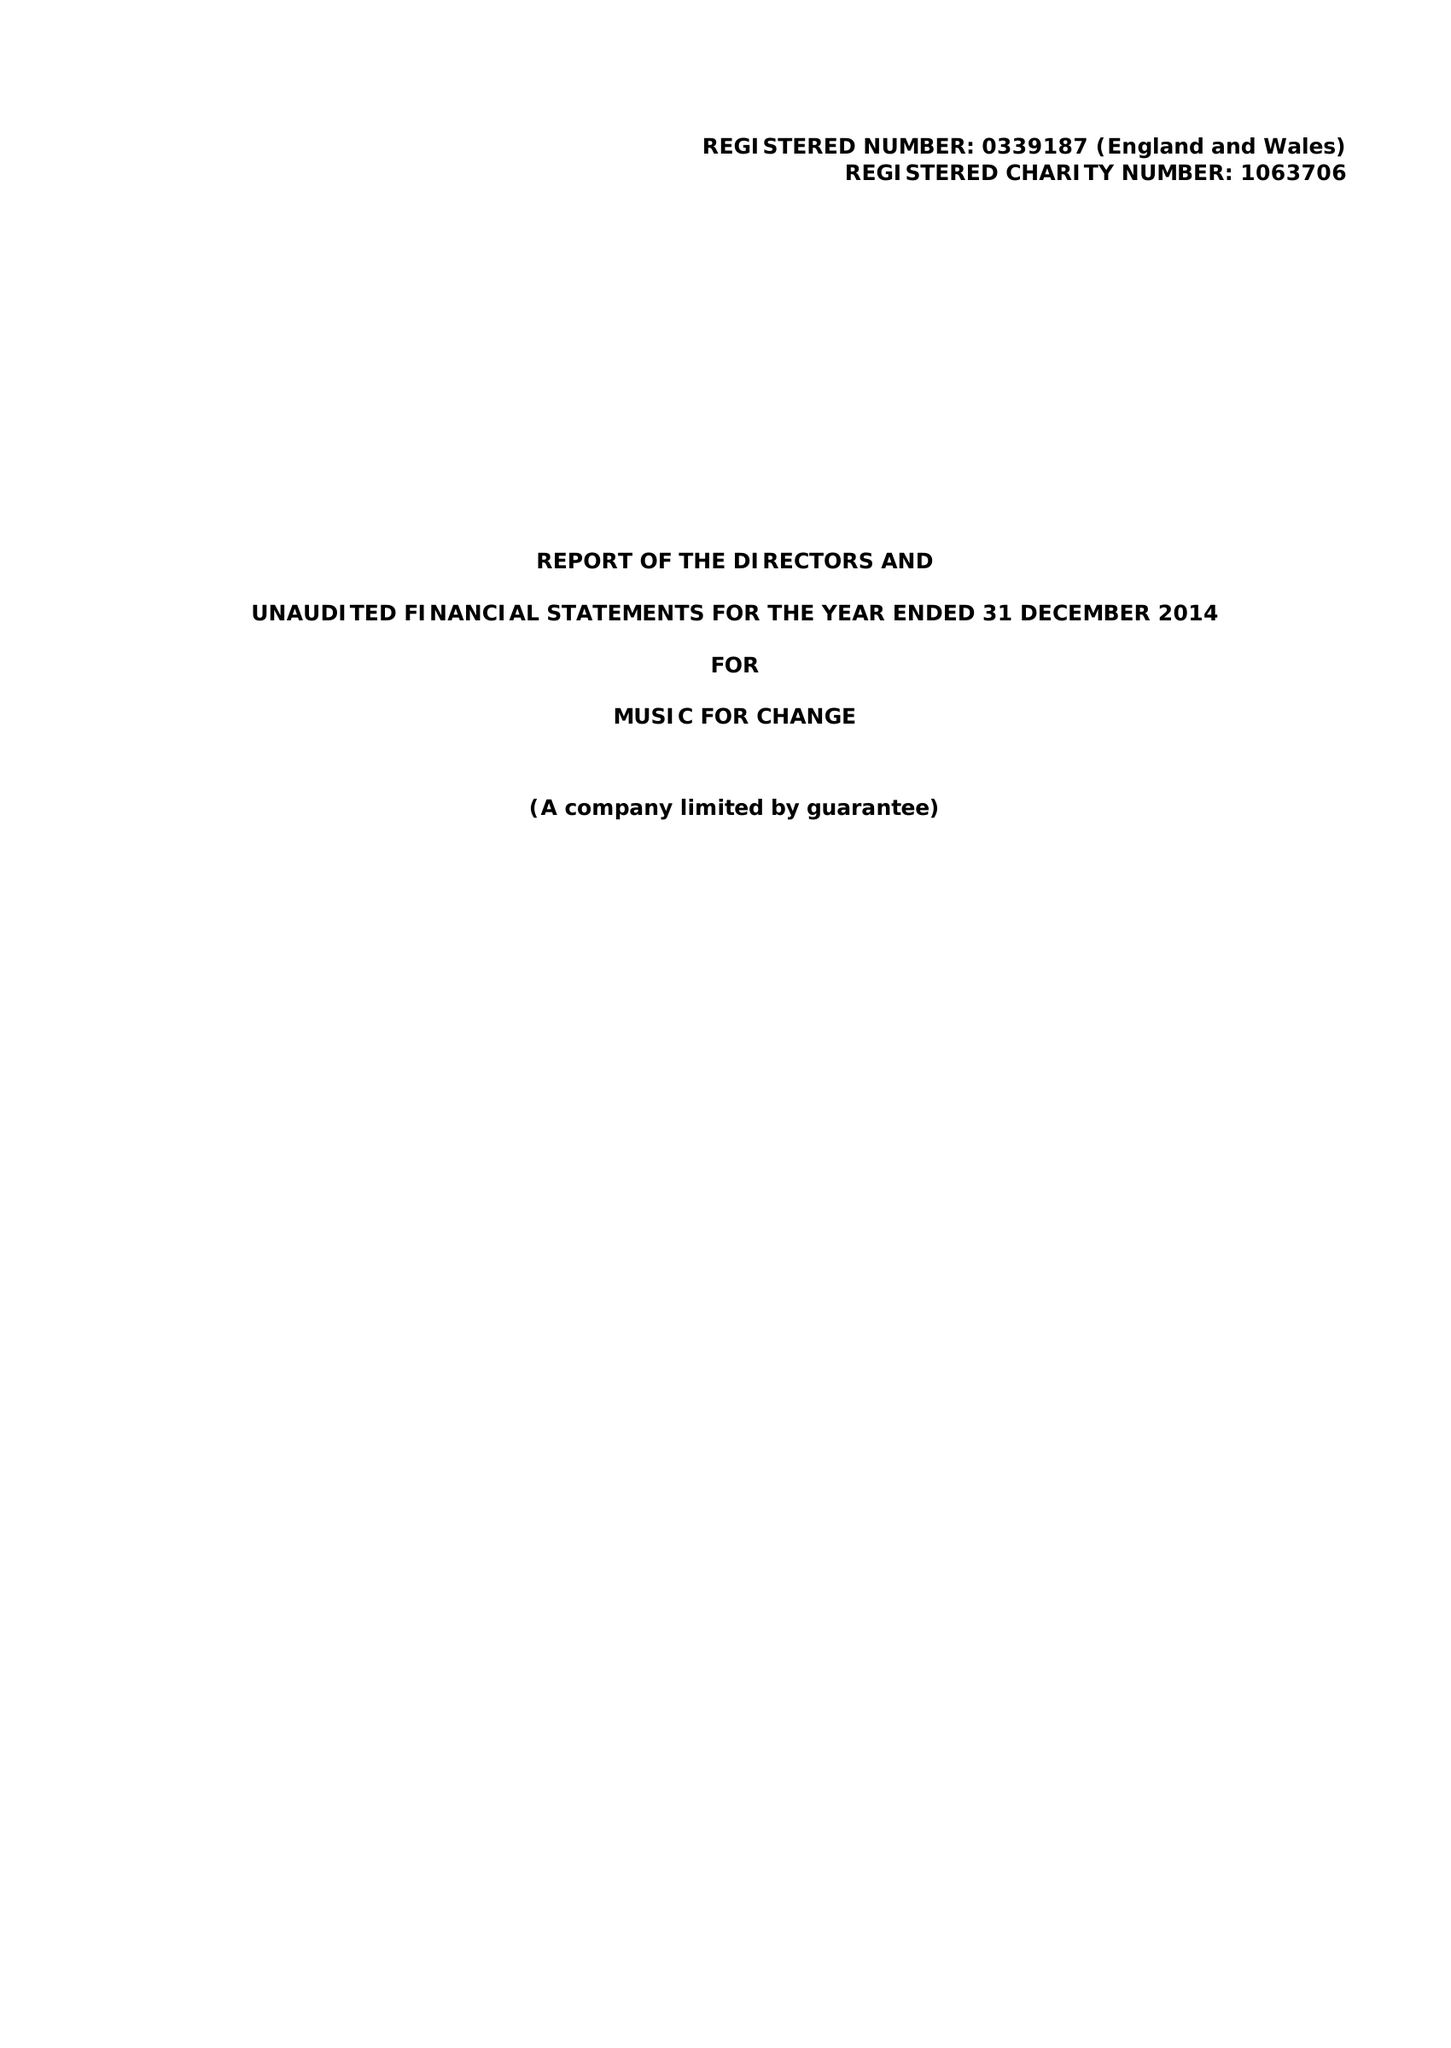What is the value for the charity_name?
Answer the question using a single word or phrase. Music For Change 